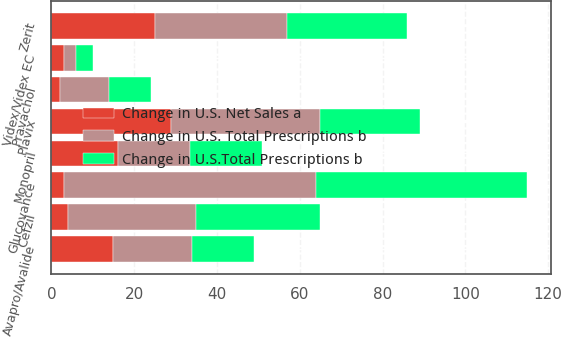Convert chart to OTSL. <chart><loc_0><loc_0><loc_500><loc_500><stacked_bar_chart><ecel><fcel>Plavix<fcel>Pravachol<fcel>Avapro/Avalide<fcel>Monopril<fcel>Videx/Videx EC<fcel>Zerit<fcel>Cefzil<fcel>Glucovance<nl><fcel>Change in U.S. Total Prescriptions b<fcel>36<fcel>12<fcel>19<fcel>17.5<fcel>3<fcel>32<fcel>31<fcel>61<nl><fcel>Change in U.S.Total Prescriptions b<fcel>24<fcel>10<fcel>15<fcel>17.5<fcel>4<fcel>29<fcel>30<fcel>51<nl><fcel>Change in U.S. Net Sales a<fcel>29<fcel>2<fcel>15<fcel>16<fcel>3<fcel>25<fcel>4<fcel>3<nl></chart> 